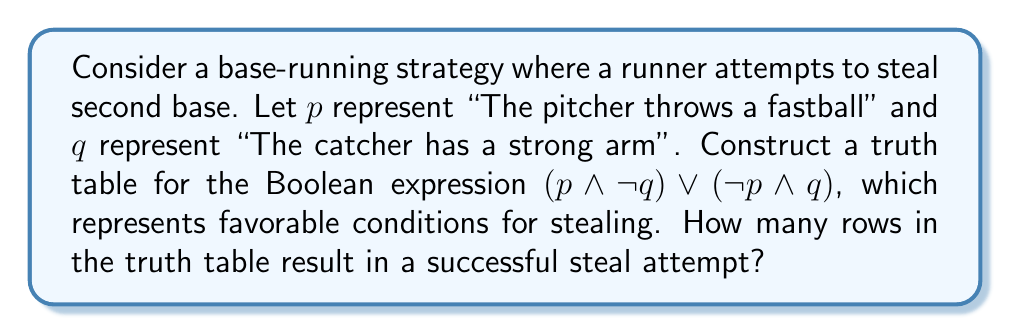Could you help me with this problem? Let's construct the truth table step-by-step:

1. First, we list all possible combinations of $p$ and $q$:

   $p$ | $q$
   ----+----
   0   | 0
   0   | 1
   1   | 0
   1   | 1

2. Now, let's evaluate $\neg q$:

   $p$ | $q$ | $\neg q$
   ----+-----+--------
   0   | 0   | 1
   0   | 1   | 0
   1   | 0   | 1
   1   | 1   | 0

3. Next, we evaluate $p \land \neg q$:

   $p$ | $q$ | $\neg q$ | $p \land \neg q$
   ----+-----+--------+--------------
   0   | 0   | 1      | 0
   0   | 1   | 0      | 0
   1   | 0   | 1      | 1
   1   | 1   | 0      | 0

4. Now, let's evaluate $\neg p$:

   $p$ | $q$ | $\neg q$ | $p \land \neg q$ | $\neg p$
   ----+-----+--------+--------------+--------
   0   | 0   | 1      | 0            | 1
   0   | 1   | 0      | 0            | 1
   1   | 0   | 1      | 1            | 0
   1   | 1   | 0      | 0            | 0

5. Next, we evaluate $\neg p \land q$:

   $p$ | $q$ | $\neg q$ | $p \land \neg q$ | $\neg p$ | $\neg p \land q$
   ----+-----+--------+--------------+--------+--------------
   0   | 0   | 1      | 0            | 1      | 0
   0   | 1   | 0      | 0            | 1      | 1
   1   | 0   | 1      | 1            | 0      | 0
   1   | 1   | 0      | 0            | 0      | 0

6. Finally, we evaluate $(p \land \neg q) \lor (\neg p \land q)$:

   $p$ | $q$ | $\neg q$ | $p \land \neg q$ | $\neg p$ | $\neg p \land q$ | $(p \land \neg q) \lor (\neg p \land q)$
   ----+-----+--------+--------------+--------+--------------+--------------------------------
   0   | 0   | 1      | 0            | 1      | 0            | 0
   0   | 1   | 0      | 0            | 1      | 1            | 1
   1   | 0   | 1      | 1            | 0      | 0            | 1
   1   | 1   | 0      | 0            | 0      | 0            | 0

Counting the number of 1's in the final column, we see that there are 2 rows where the expression is true, representing favorable conditions for stealing.
Answer: 2 